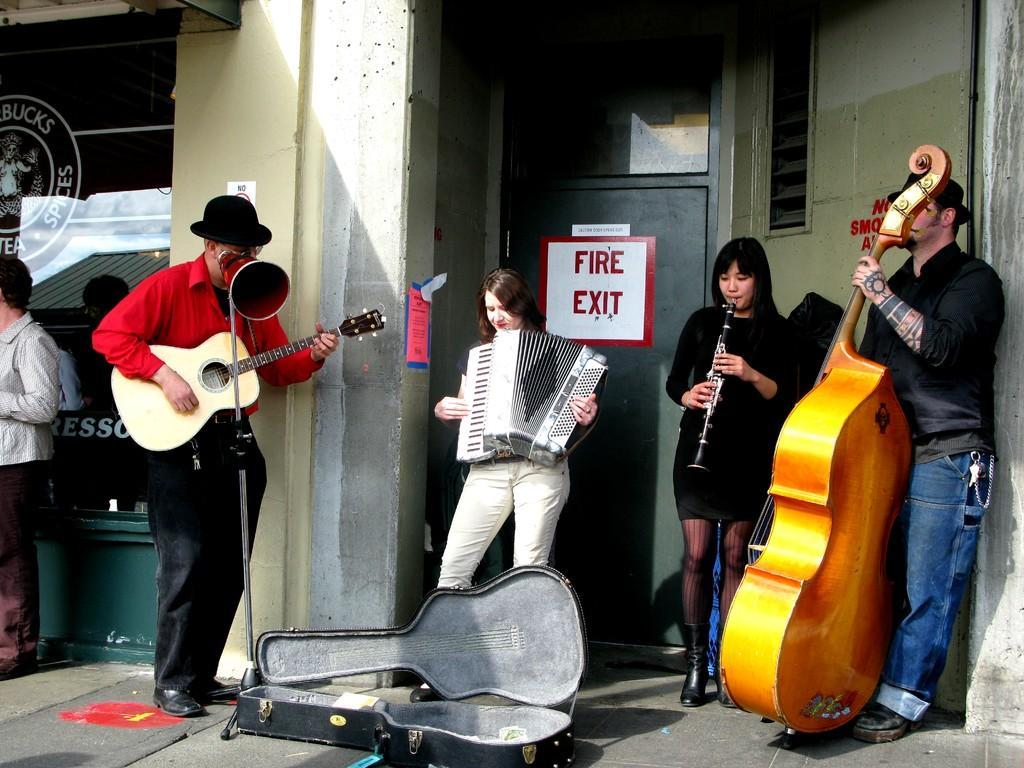How would you summarize this image in a sentence or two? In this image there are group of persons who are standing on the floor and playing musical instruments. 